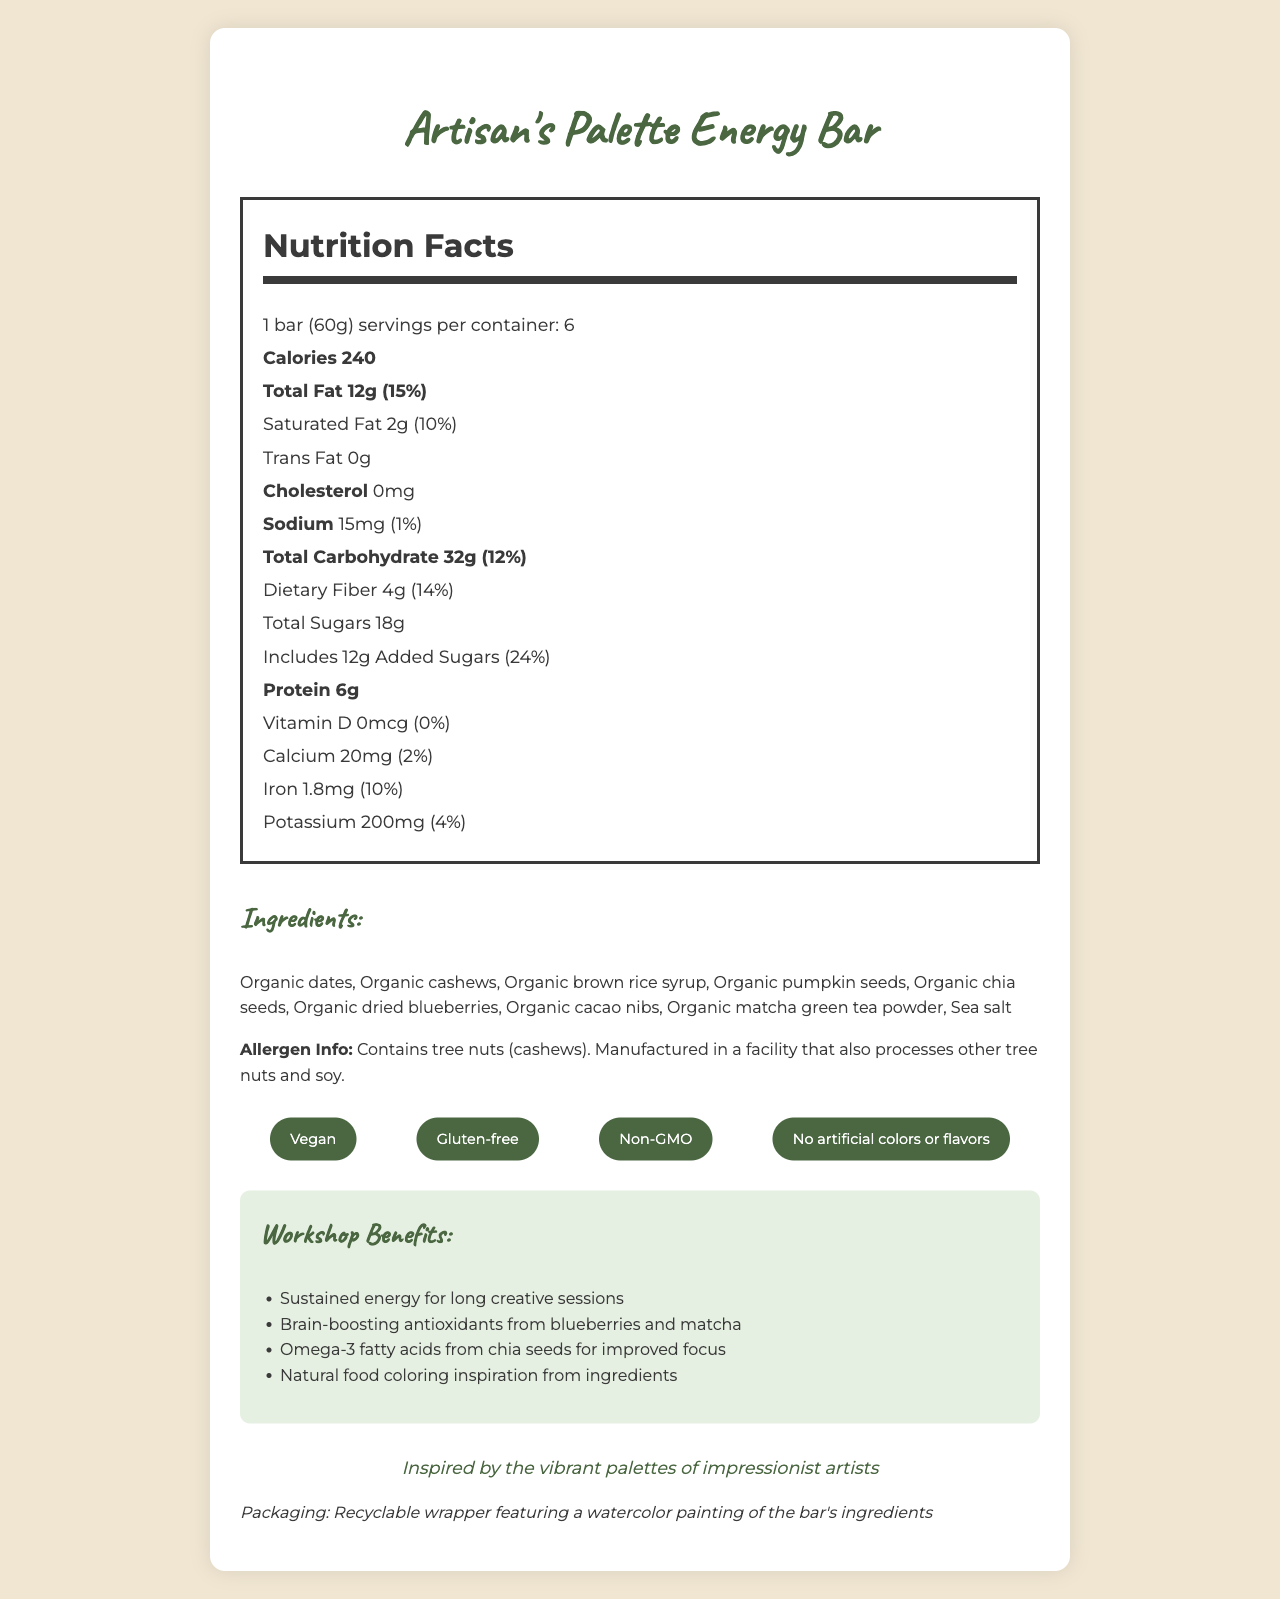what is the serving size of the "Artisan's Palette Energy Bar"? The document states that the serving size is 1 bar (60g).
Answer: 1 bar (60g) how many servings are there per container? The document mentions that there are 6 servings per container.
Answer: 6 how much total fat does one serving contain? The document indicates that one serving contains 12g of total fat.
Answer: 12g what are the main ingredients of the bar? The ingredients list provides the main ingredients of the bar.
Answer: Organic dates, Organic cashews, Organic brown rice syrup, Organic pumpkin seeds, Organic chia seeds, Organic dried blueberries, Organic cacao nibs, Organic matcha green tea powder, Sea salt how much protein is in one serving? The nutrition label shows that one serving contains 6g of protein.
Answer: 6g which vitamin is not present in the bar? A. Vitamin A B. Vitamin C C. Vitamin D D. Vitamin E The document states that Vitamin D is present in 0mcg, which is 0% of the daily value, implying it is not present.
Answer: C. Vitamin D which nutrient has a daily value of 24%? A. Total Fat B. Saturated Fat C. Added Sugars D. Dietary Fiber The document shows that added sugars have a daily value of 24%.
Answer: C. Added Sugars is the bar gluten-free? Under claims, the document states that the bar is gluten-free.
Answer: Yes does the "Artisan's Palette Energy Bar" contain artificial colors or flavors? The document claims that there are no artificial colors or flavors in the bar.
Answer: No summarize the key information presented in the document. The document provides detailed information about the nutritional content, ingredients, and special benefits of the "Artisan's Palette Energy Bar," emphasizing its suitability for creative workshops and eco-friendly packaging.
Answer: The "Artisan's Palette Energy Bar" is a vegan, gluten-free, and non-GMO snack bar designed for creative workshops. It comes in a 60g serving size, with each serving providing 240 calories and a variety of nutrients including 12g of total fat, 6g of protein, and 32g of carbohydrates. The main ingredients include organic dates, cashews, brown rice syrup, and other natural components. The bar is packaged in a recyclable wrapper featuring a watercolor painting. Additionally, it offers benefits such as sustained energy and improved focus, crucial for long creative sessions. how much dietary fiber is provided in one serving? The nutrition label lists that one serving contains 4g of dietary fiber.
Answer: 4g what is the daily value percentage of iron in one serving? The nutrition label details that the daily value percentage for iron is 10%.
Answer: 10% what is the artistic inspiration for the bar's packaging? The special note in the document mentions that the packaging is inspired by the vibrant palettes of impressionist artists.
Answer: Inspired by the vibrant palettes of impressionist artists how much sodium does the bar contain per serving? The nutrition facts state that the bar contains 15mg of sodium per serving.
Answer: 15mg what are the main benefits of consuming the "Artisan's Palette Energy Bar" during a workshop? The workshop benefits section lists these benefits as key advantages of consuming the bar.
Answer: Sustained energy, brain-boosting antioxidants, improved focus, natural food coloring inspiration how much calcium is in each serving of the bar? The nutrition label indicates each serving contains 20mg of calcium.
Answer: 20mg which of these ingredients is not part of the bar? A. Organic Chia Seeds B. Organic Dried Blueberries C. Organic Matcha Green Tea Powder D. Honey The ingredients list does not include honey, making it clear it is not part of the bar.
Answer: D. Honey can people with nut allergies consume this bar safely? The allergen info warns that the bar contains tree nuts (cashews) and is manufactured in a facility that processes other tree nuts and soy.
Answer: No what type of wrapper is used for the bar's packaging? The document mentions that the bar's packaging is a recyclable wrapper.
Answer: Recyclable wrapper 